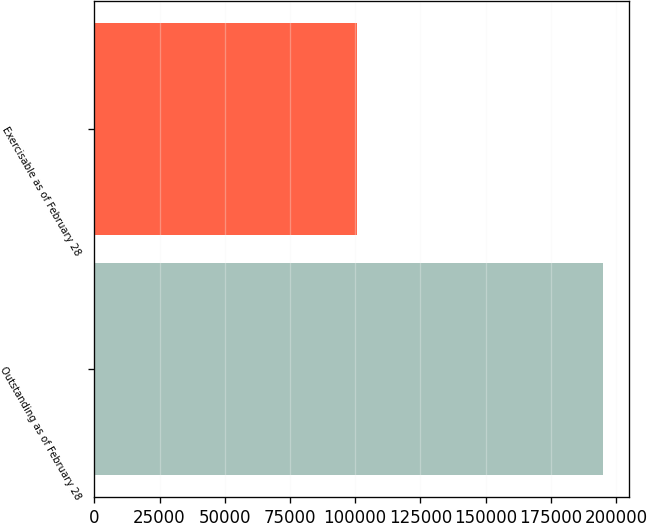Convert chart. <chart><loc_0><loc_0><loc_500><loc_500><bar_chart><fcel>Outstanding as of February 28<fcel>Exercisable as of February 28<nl><fcel>195134<fcel>100545<nl></chart> 